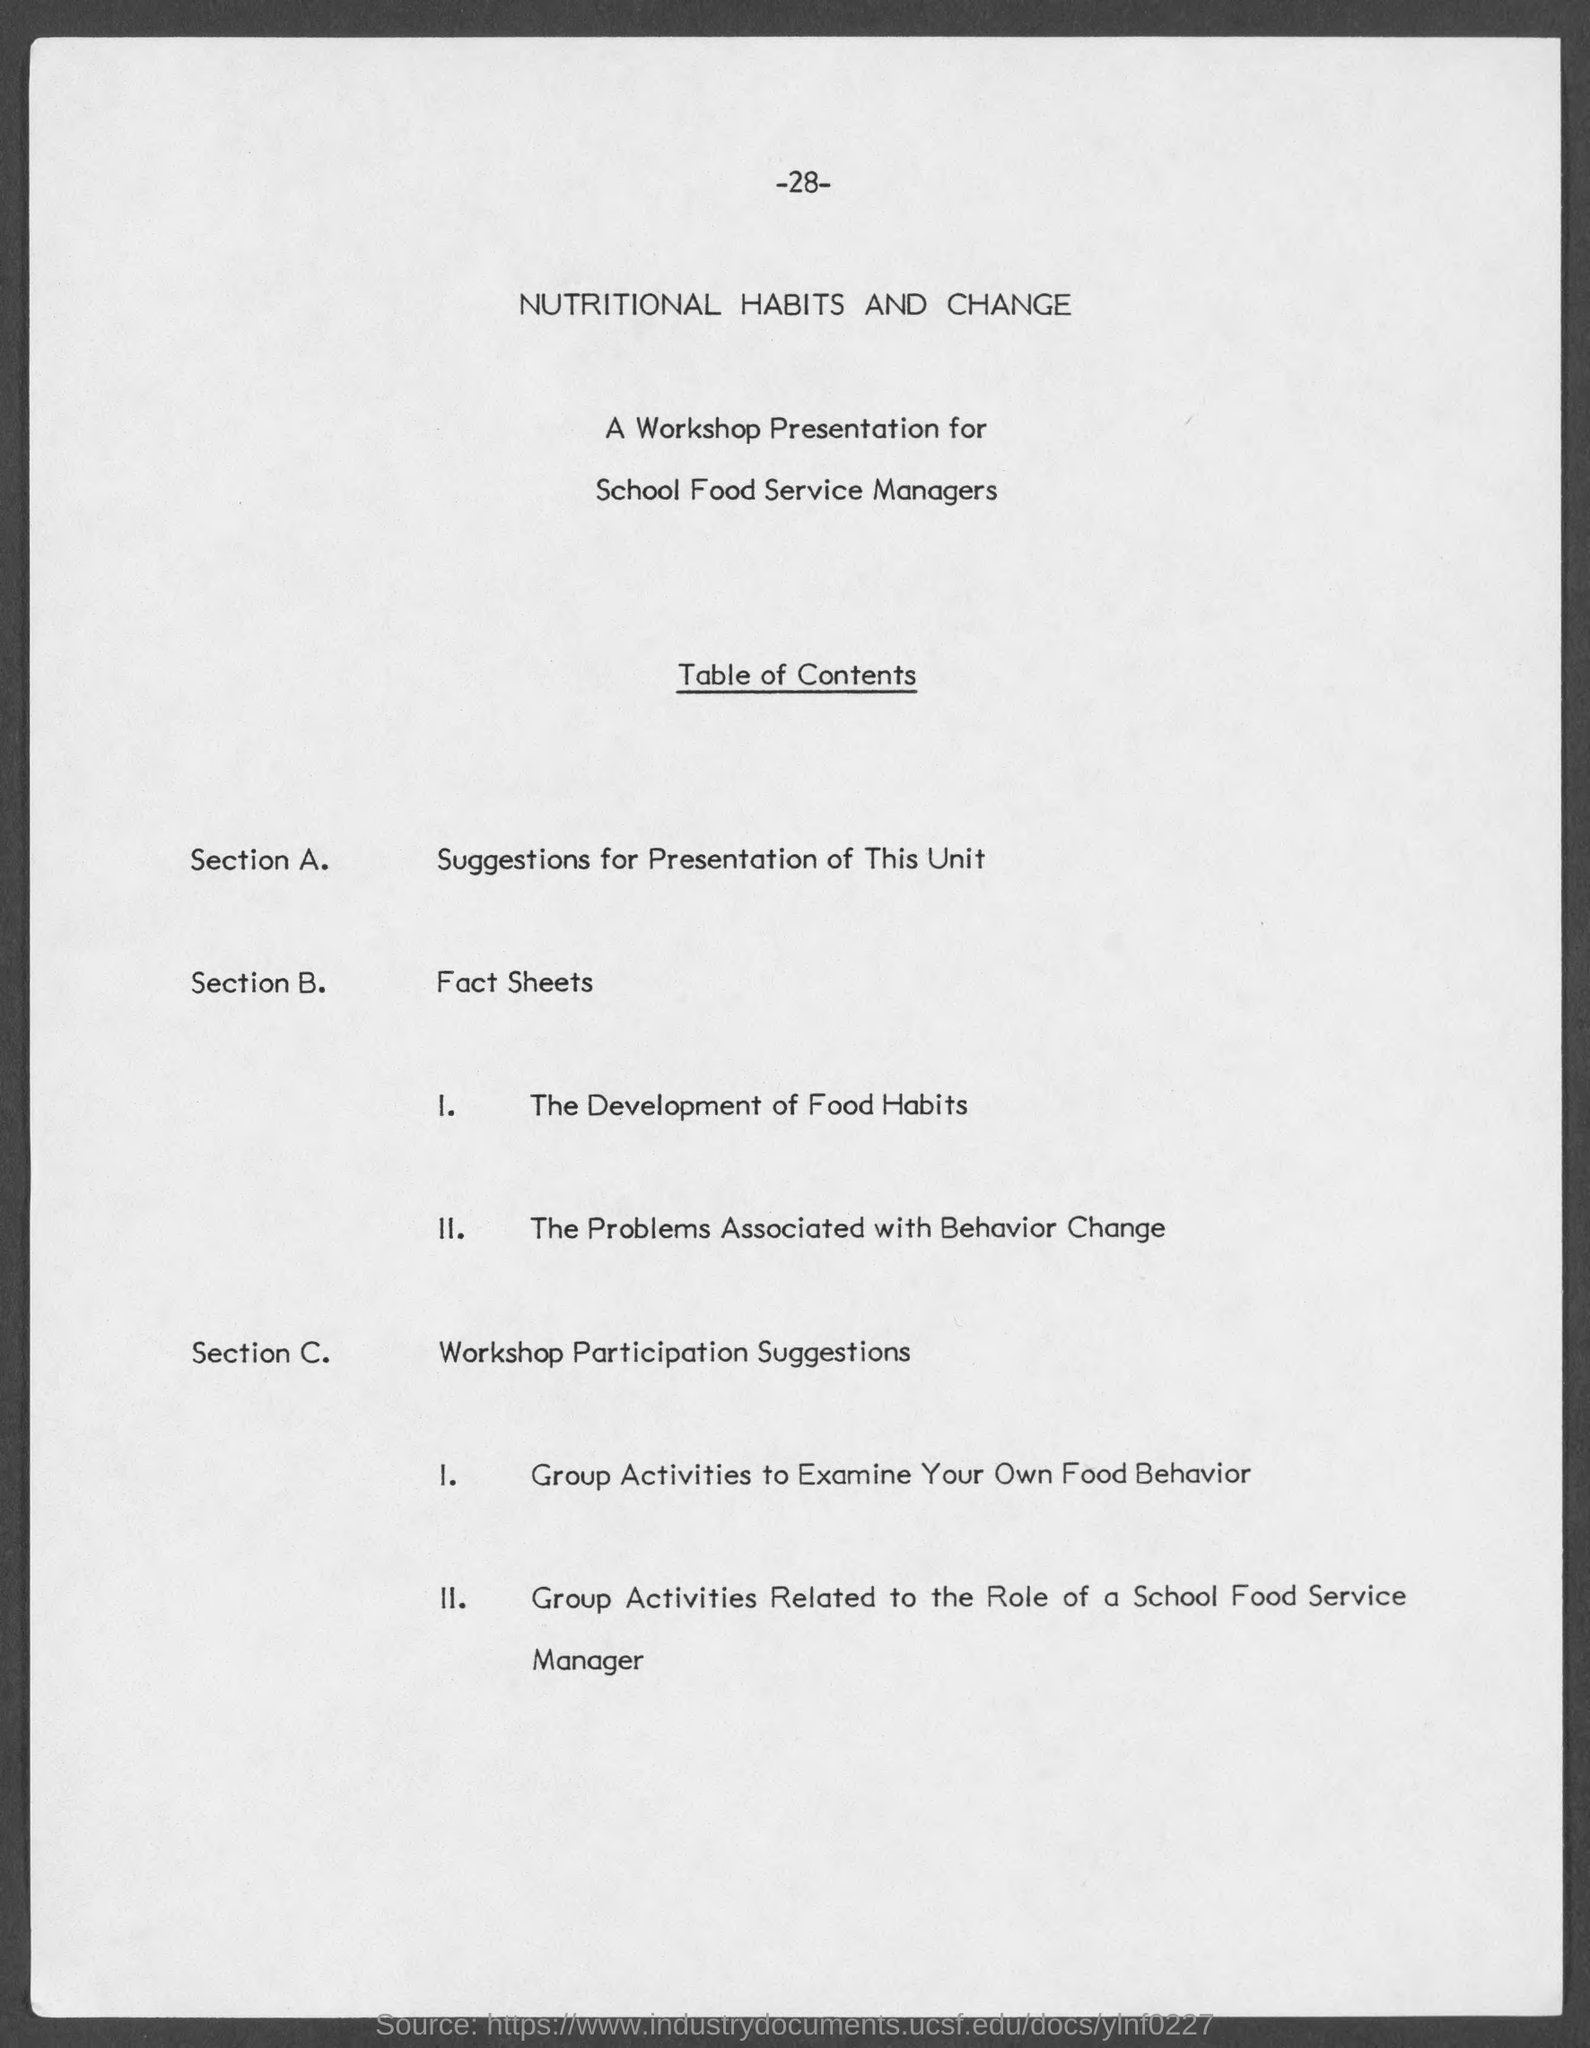Outline some significant characteristics in this image. Section C deals with workshop participation suggestions. Section B addresses fact sheets. The page number at the top of the page is -28-. Section A deals with the presentation of this unit. 